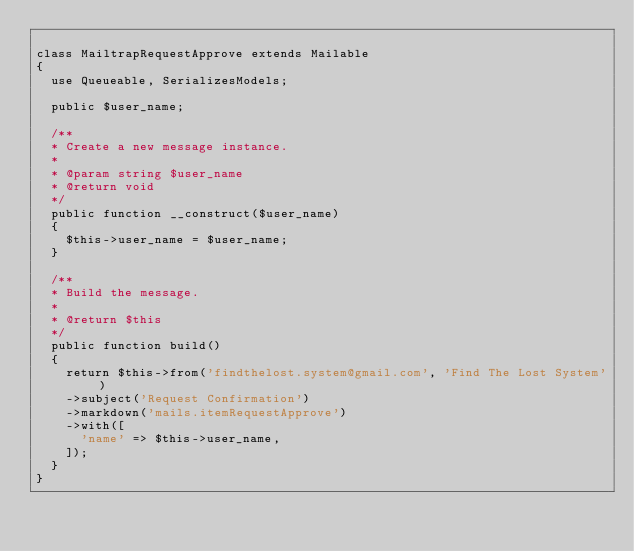Convert code to text. <code><loc_0><loc_0><loc_500><loc_500><_PHP_>
class MailtrapRequestApprove extends Mailable
{
  use Queueable, SerializesModels;

  public $user_name;

  /**
  * Create a new message instance.
  *
  * @param string $user_name
  * @return void
  */
  public function __construct($user_name)
  {
    $this->user_name = $user_name;
  }

  /**
  * Build the message.
  *
  * @return $this
  */
  public function build()
  {
    return $this->from('findthelost.system@gmail.com', 'Find The Lost System')
    ->subject('Request Confirmation')
    ->markdown('mails.itemRequestApprove')
    ->with([
      'name' => $this->user_name,
    ]);
  }
}
</code> 